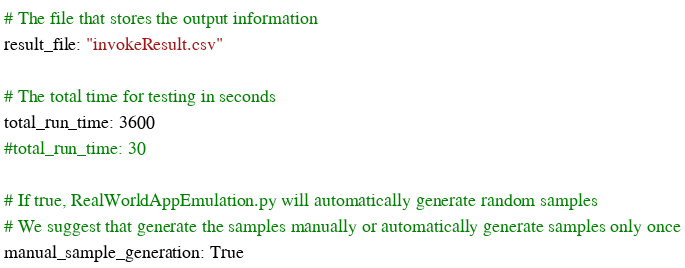<code> <loc_0><loc_0><loc_500><loc_500><_YAML_># The file that stores the output information
result_file: "invokeResult.csv"

# The total time for testing in seconds
total_run_time: 3600
#total_run_time: 30

# If true, RealWorldAppEmulation.py will automatically generate random samples
# We suggest that generate the samples manually or automatically generate samples only once
manual_sample_generation: True
</code> 